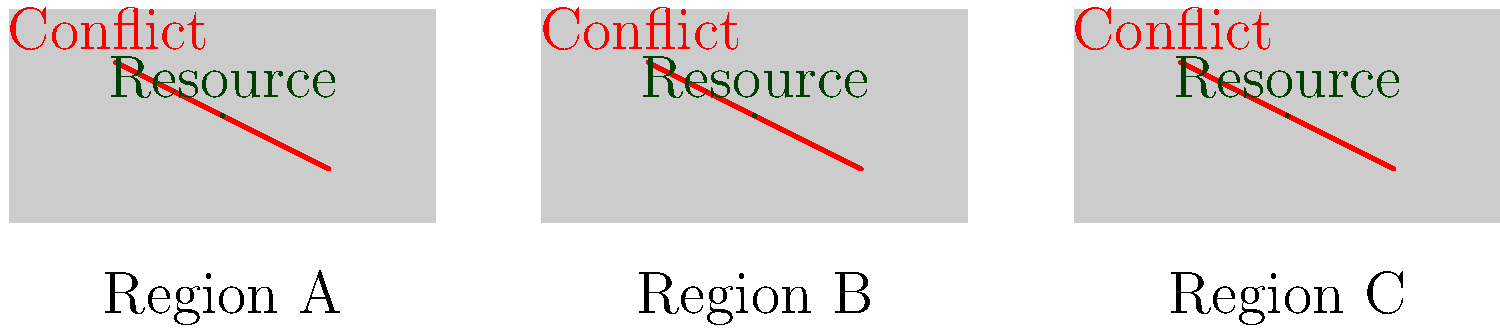Based on the resource distribution map showing three regions (A, B, and C) with equal resource deposits and conflict hotspots, what conclusion can be drawn about the relationship between natural resource distribution and international conflicts in this scenario? How might this inform geopolitical strategies? To answer this question, let's analyze the map step-by-step:

1. Resource distribution:
   - Each region (A, B, and C) has one resource deposit.
   - The resources appear to be equally distributed across the regions.

2. Conflict hotspots:
   - Each region has one conflict hotspot.
   - The conflicts are consistently present across all regions.

3. Correlation analysis:
   - Despite equal resource distribution, conflicts persist in all regions.
   - This suggests that resource distribution alone does not explain the conflicts.

4. Potential factors:
   - Resource scarcity is unlikely to be the primary cause of conflicts.
   - Other factors such as political, ethnic, or historical tensions may be at play.

5. Geopolitical implications:
   - Focusing solely on resource management may not resolve these conflicts.
   - A comprehensive approach addressing underlying socio-political issues is necessary.

6. Strategy considerations:
   - Diplomatic efforts should focus on non-resource related conflict drivers.
   - Economic development and regional cooperation initiatives may be beneficial.
   - Conflict resolution strategies should be tailored to each region's specific context.

In conclusion, the map shows that equal resource distribution does not prevent conflicts, indicating that other factors are likely driving the tensions in these regions. This insight suggests that geopolitical strategies should look beyond resource management to address the root causes of these conflicts.
Answer: Resource distribution alone does not explain conflicts; other socio-political factors likely drive tensions, necessitating comprehensive geopolitical strategies beyond resource management. 